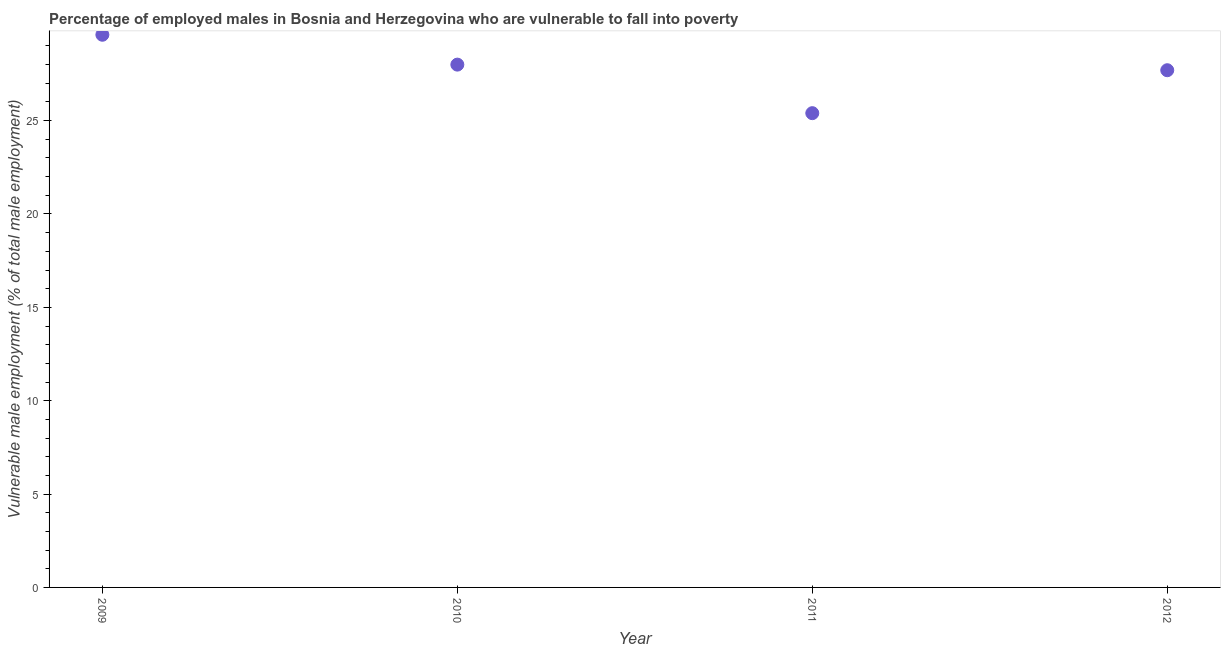What is the percentage of employed males who are vulnerable to fall into poverty in 2012?
Ensure brevity in your answer.  27.7. Across all years, what is the maximum percentage of employed males who are vulnerable to fall into poverty?
Offer a terse response. 29.6. Across all years, what is the minimum percentage of employed males who are vulnerable to fall into poverty?
Ensure brevity in your answer.  25.4. What is the sum of the percentage of employed males who are vulnerable to fall into poverty?
Your answer should be compact. 110.7. What is the difference between the percentage of employed males who are vulnerable to fall into poverty in 2009 and 2011?
Provide a succinct answer. 4.2. What is the average percentage of employed males who are vulnerable to fall into poverty per year?
Ensure brevity in your answer.  27.68. What is the median percentage of employed males who are vulnerable to fall into poverty?
Provide a succinct answer. 27.85. In how many years, is the percentage of employed males who are vulnerable to fall into poverty greater than 7 %?
Offer a very short reply. 4. What is the ratio of the percentage of employed males who are vulnerable to fall into poverty in 2009 to that in 2011?
Provide a succinct answer. 1.17. Is the percentage of employed males who are vulnerable to fall into poverty in 2009 less than that in 2010?
Ensure brevity in your answer.  No. Is the difference between the percentage of employed males who are vulnerable to fall into poverty in 2010 and 2011 greater than the difference between any two years?
Offer a very short reply. No. What is the difference between the highest and the second highest percentage of employed males who are vulnerable to fall into poverty?
Your response must be concise. 1.6. Is the sum of the percentage of employed males who are vulnerable to fall into poverty in 2009 and 2011 greater than the maximum percentage of employed males who are vulnerable to fall into poverty across all years?
Give a very brief answer. Yes. What is the difference between the highest and the lowest percentage of employed males who are vulnerable to fall into poverty?
Provide a succinct answer. 4.2. Does the percentage of employed males who are vulnerable to fall into poverty monotonically increase over the years?
Make the answer very short. No. How many years are there in the graph?
Keep it short and to the point. 4. What is the difference between two consecutive major ticks on the Y-axis?
Your response must be concise. 5. Does the graph contain any zero values?
Offer a terse response. No. What is the title of the graph?
Keep it short and to the point. Percentage of employed males in Bosnia and Herzegovina who are vulnerable to fall into poverty. What is the label or title of the Y-axis?
Your response must be concise. Vulnerable male employment (% of total male employment). What is the Vulnerable male employment (% of total male employment) in 2009?
Ensure brevity in your answer.  29.6. What is the Vulnerable male employment (% of total male employment) in 2011?
Your response must be concise. 25.4. What is the Vulnerable male employment (% of total male employment) in 2012?
Offer a terse response. 27.7. What is the difference between the Vulnerable male employment (% of total male employment) in 2009 and 2010?
Give a very brief answer. 1.6. What is the difference between the Vulnerable male employment (% of total male employment) in 2009 and 2011?
Make the answer very short. 4.2. What is the difference between the Vulnerable male employment (% of total male employment) in 2009 and 2012?
Keep it short and to the point. 1.9. What is the difference between the Vulnerable male employment (% of total male employment) in 2010 and 2011?
Your response must be concise. 2.6. What is the difference between the Vulnerable male employment (% of total male employment) in 2010 and 2012?
Offer a terse response. 0.3. What is the ratio of the Vulnerable male employment (% of total male employment) in 2009 to that in 2010?
Your response must be concise. 1.06. What is the ratio of the Vulnerable male employment (% of total male employment) in 2009 to that in 2011?
Offer a terse response. 1.17. What is the ratio of the Vulnerable male employment (% of total male employment) in 2009 to that in 2012?
Offer a very short reply. 1.07. What is the ratio of the Vulnerable male employment (% of total male employment) in 2010 to that in 2011?
Provide a short and direct response. 1.1. What is the ratio of the Vulnerable male employment (% of total male employment) in 2010 to that in 2012?
Your answer should be compact. 1.01. What is the ratio of the Vulnerable male employment (% of total male employment) in 2011 to that in 2012?
Your response must be concise. 0.92. 